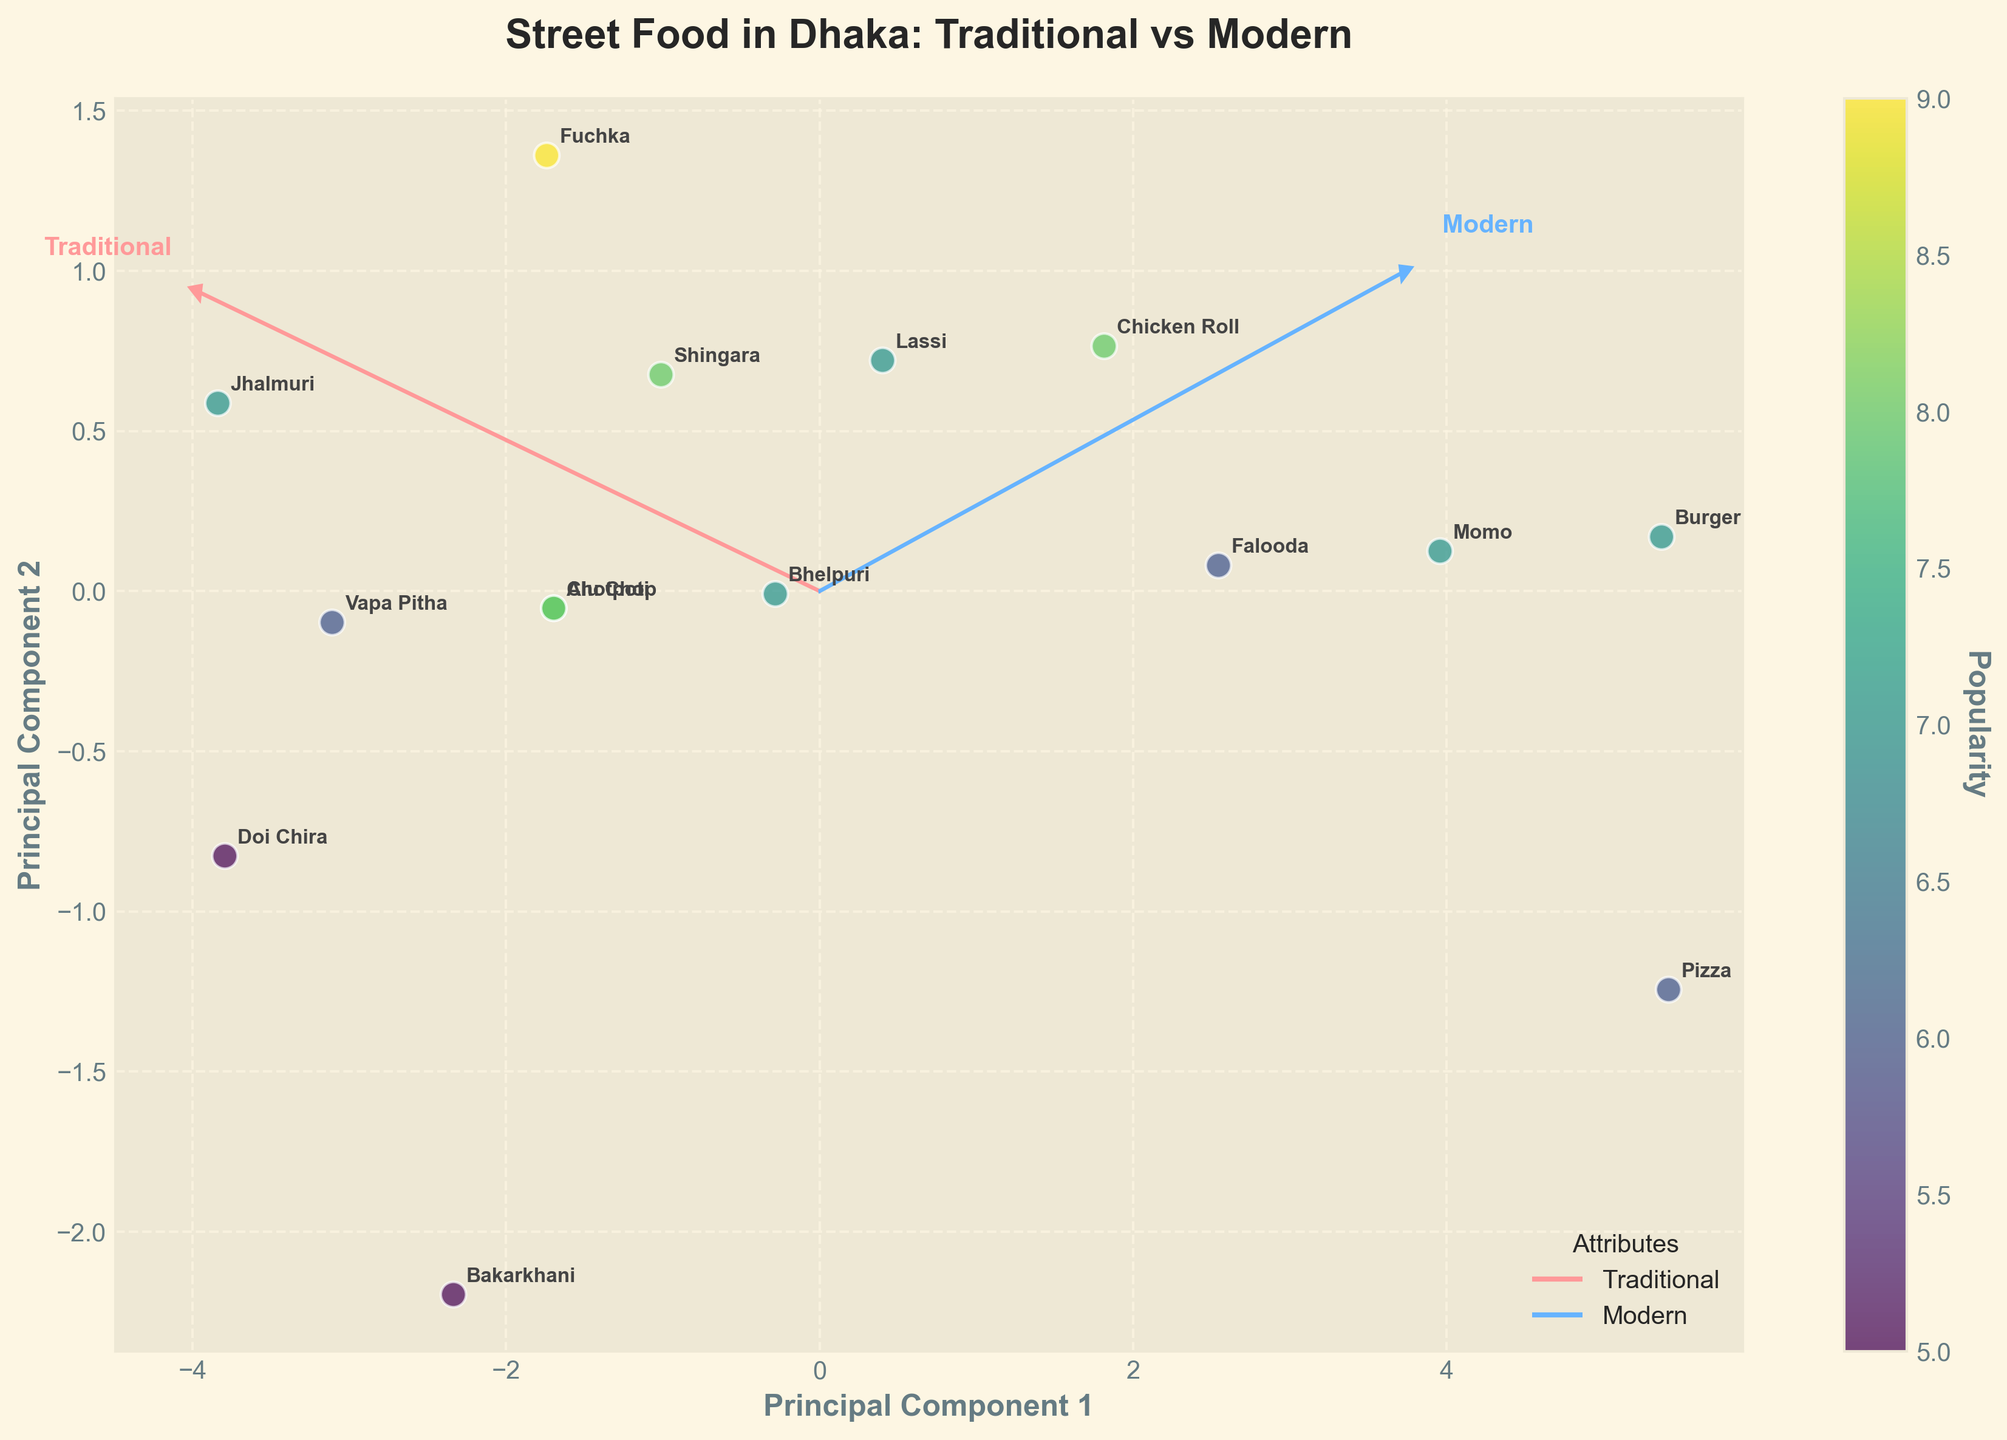What is the title of the biplot? The title of the biplot is generally located at the top of the figure. It provides a brief description that conveys the main point or subject of the plot. In this case, the title "Street Food in Dhaka: Traditional vs Modern" is clearly displayed, indicating the comparison of traditional and modern street food offerings in Dhaka.
Answer: Street Food in Dhaka: Traditional vs Modern How many food items are represented in the plot? To find the number of food items represented, count the labels annotating the data points in the figure. Each label represents a unique food item.
Answer: 15 Which food item appears to have the highest popularity score? To determine which food item has the highest popularity, look for the data point associated with the maximum color value (indicating high popularity) on the color bar. The label closest to this point represents the food item with the highest popularity.
Answer: Fuchka Between Traditional and Modern scores, which score axis contributes more to Vapa Pitha's position in the biplot? By analyzing the projection of Vapa Pitha on the biplot's principal components, you will see how far it is along the vectors representing Traditional and Modern scores. The longer the projection along a particular vector, the greater the contribution of that score axis.
Answer: Traditional Which vector (Traditional or Modern) seems to align more closely with popular food items? To determine this, observe the direction of the gradient of popular food items. If the majority of highly popular food items align more closely or have a higher projection along either the Traditional or Modern vector, that informs which vector is more aligned.
Answer: Traditional What is the Traditional score and Popularity of the food item positioned nearest to both principal component axes? Identify the data point closest to the origin (0,0) of the principal component axes and refer to its corresponding Traditional score and Popularity from the dataset.
Answer: Lassi, Traditional Score: 6, Popularity: 7 Which food item is projected farthest along the principal component representing modernization? Determine the item with the highest Modern Score projection (positive along the PC2 axis), taking into account the arrow direction indicating modernization.
Answer: Burger Compare Fuchka and Pizza in terms of their Traditional score and Modern score. Which one is more traditional, and which one is more modern? Fuchka has a Traditional score of 8 and Modern score of 5, while Pizza has a Traditional score of 1 and Modern score of 8. By comparison, Fuchka scores higher on the Traditional axis, making it more traditional, and Pizza scores higher on the Modern axis, making it more modern.
Answer: Fuchka: more traditional, Pizza: more modern 